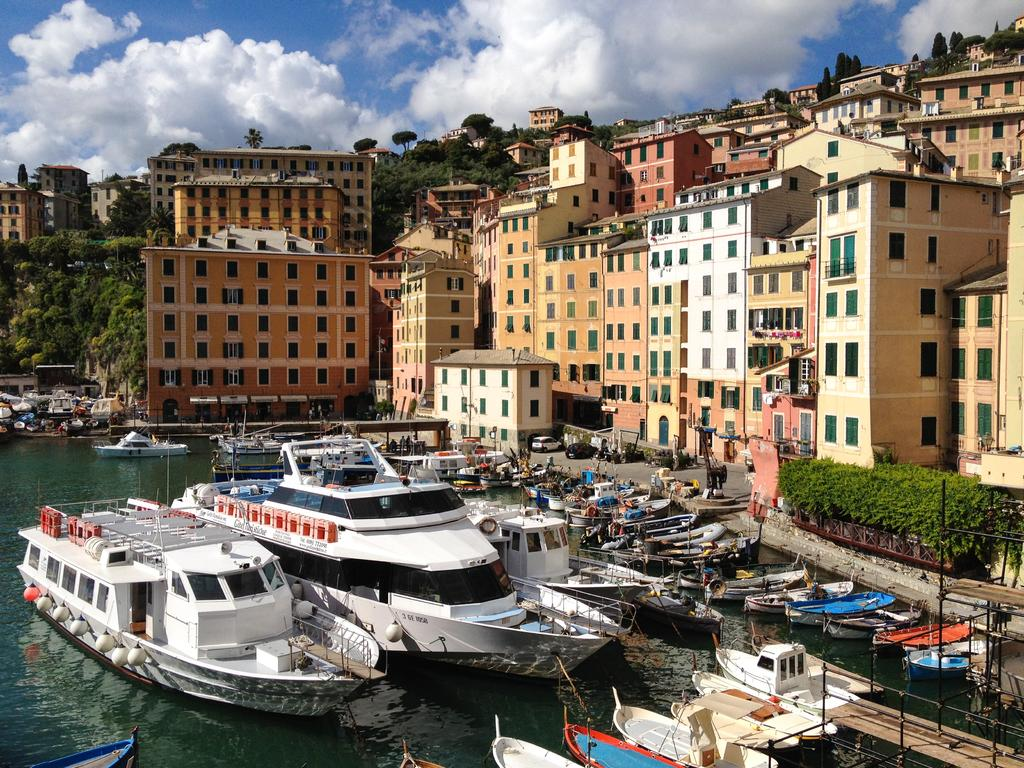What is on the water in the image? There are boats on the water in the image. What structures are beside the boats? There are metal rods beside the boats. What type of vegetation can be seen in the image? Shrubs and trees are present in the image. What type of structures are visible in the image? Buildings are visible in the image. What is visible in the sky in the image? Clouds are visible in the image. Where can the clocks be found in the image? There are no clocks present in the image. What does the place look like in the image? The provided facts do not give any information about the place or location of the image, so it cannot be described. 